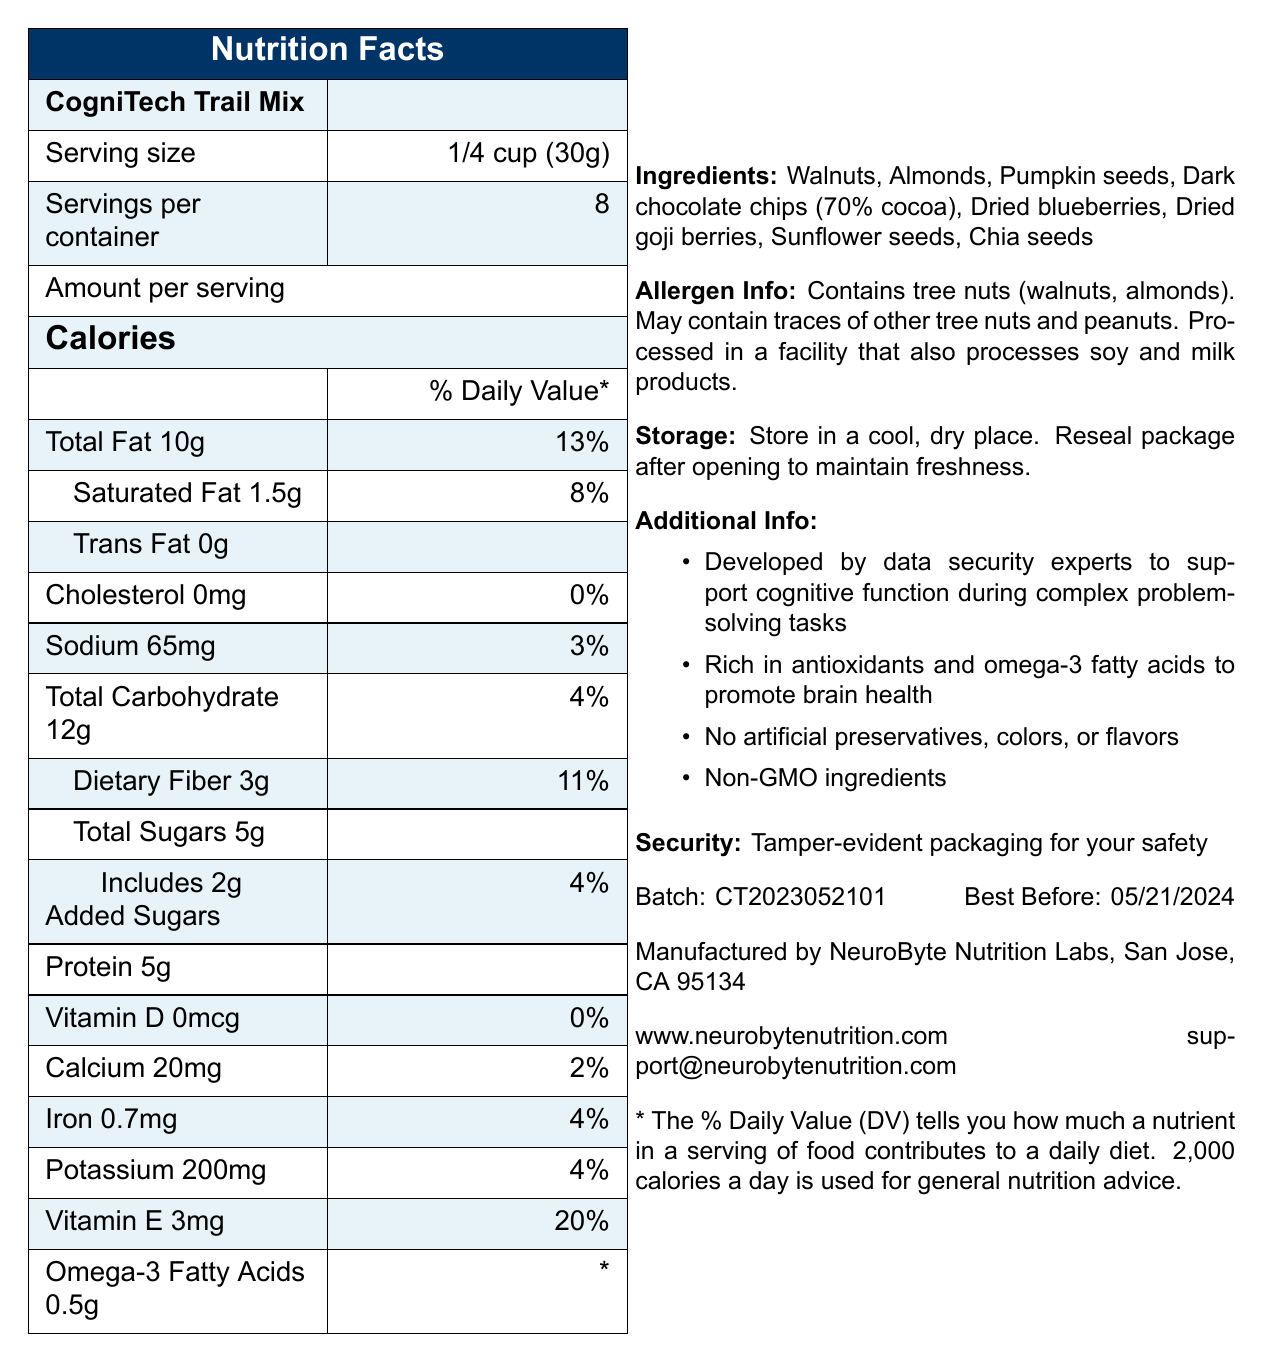what is the serving size of the CogniTech Trail Mix? The serving size is directly specified in the document under the "Serving size" section.
Answer: 1/4 cup (30g) how many calories are there per serving? The calories per serving are listed as 150 in the "Amount per serving" section.
Answer: 150 how much saturated fat is in one serving? The amount of saturated fat per serving is mentioned as 1.5g under the "Total Fat" section.
Answer: 1.5g what is the total fat content per serving and its daily value percentage? The total fat content per serving is 10g with a daily value of 13%, as mentioned in the document.
Answer: 10g, 13% what are the ingredients listed in the CogniTech Trail Mix? The ingredients are detailed in the "Ingredients" section of the document.
Answer: Walnuts, Almonds, Pumpkin seeds, Dark chocolate chips (70% cocoa), Dried blueberries, Dried goji berries, Sunflower seeds, Chia seeds how many grams of dietary fiber are in a serving? The dietary fiber content per serving is 3g, as shown in the "Total Carbohydrate" section.
Answer: 3g Which of the following nutrients has the highest daily value percentage? A) Vitamin D B) Calcium C) Iron D) Vitamin E Vitamin E has the highest daily value percentage of 20%, as compared to the others listed.
Answer: D) Vitamin E What is the sodium content per serving? A) 20mg B) 65mg C) 100mg D) 150mg The sodium content is 65mg per serving, as listed in the "Sodium" section.
Answer: B) 65mg is the CogniTech Trail Mix non-GMO? The document states that the ingredients are non-GMO in the "Additional Info" section.
Answer: Yes does the product contain any tree nuts? The document explicitly mentions that it contains tree nuts (walnuts, almonds) in the "Allergen Info" section.
Answer: Yes what is the protein content per serving of this product? The protein content per serving is 5g, as specified in the document.
Answer: 5g when is the best before date for this product? The best before date is listed as 05/21/2024 in the "Batch: CT2023052101 \hfill Best Before:" section.
Answer: 05/21/2024 describe the allergen information provided for CogniTech Trail Mix. The document provides detailed allergen information about tree nuts, other potential traces of allergens, and the processing facility.
Answer: Contains tree nuts (walnuts, almonds). May contain traces of other tree nuts and peanuts. Processed in a facility that also processes soy and milk products. what is the security measure listed for the product packaging? The security measure for the product packaging is mentioned as "Tamper-evident packaging" in the "Additional Info" section.
Answer: Tamper-evident packaging how much omega-3 fatty acids does one serving contain, and what is the daily value percentage? One serving contains 0.5g of omega-3 fatty acids, and the daily value percentage is indicated with an asterisk, implying additional details may be necessary to fully interpret this value.
Answer: 0.5g, * can you confirm if there are any artificial preservatives in this product? The document specifies that there are no artificial preservatives in the "Additional Info" section.
Answer: No who manufactures the CogniTech Trail Mix? The manufacturer is listed as NeuroByte Nutrition Labs, located in San Jose, CA 95134.
Answer: NeuroByte Nutrition Labs, San Jose, CA 95134 how many servings are there in one container? The number of servings per container is 8, as indicated in the document.
Answer: 8 what is the main idea of the document? The document offers comprehensive information on nutritional content, serving size, daily value percentages, ingredients, allergen warnings, non-GMO status, and additional relevant details to inform consumers about the CogniTech Trail Mix.
Answer: The document provides the nutritional facts, ingredients, allergen information, storage instructions, and additional details for the CogniTech Trail Mix, a product designed to support cognitive function. how much does the product weigh in total if the serving size is 30g and there are 8 servings per container? The total weight of the product in the container is not explicitly listed in the document; it can be inferred by multiplying the serving size by the number of servings, but this isn't directly specified in the document.
Answer: Cannot be determined 